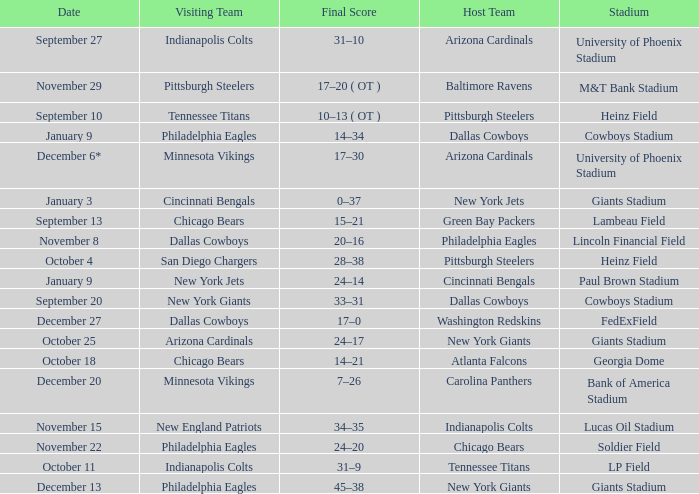Tell me the date for pittsburgh steelers November 29. 